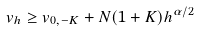<formula> <loc_0><loc_0><loc_500><loc_500>v _ { h } \geq v _ { 0 , - K } + N ( 1 + K ) h ^ { \alpha / 2 }</formula> 